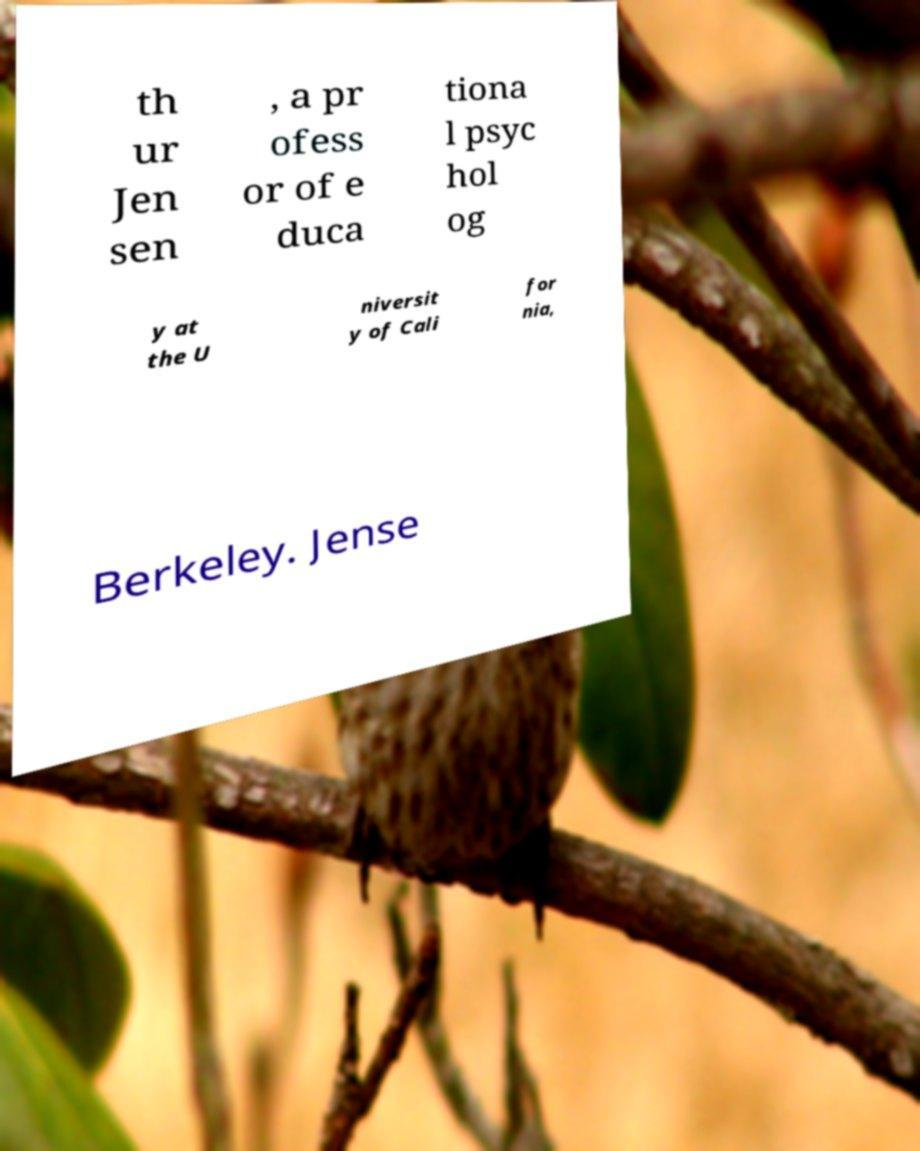Can you read and provide the text displayed in the image?This photo seems to have some interesting text. Can you extract and type it out for me? th ur Jen sen , a pr ofess or of e duca tiona l psyc hol og y at the U niversit y of Cali for nia, Berkeley. Jense 